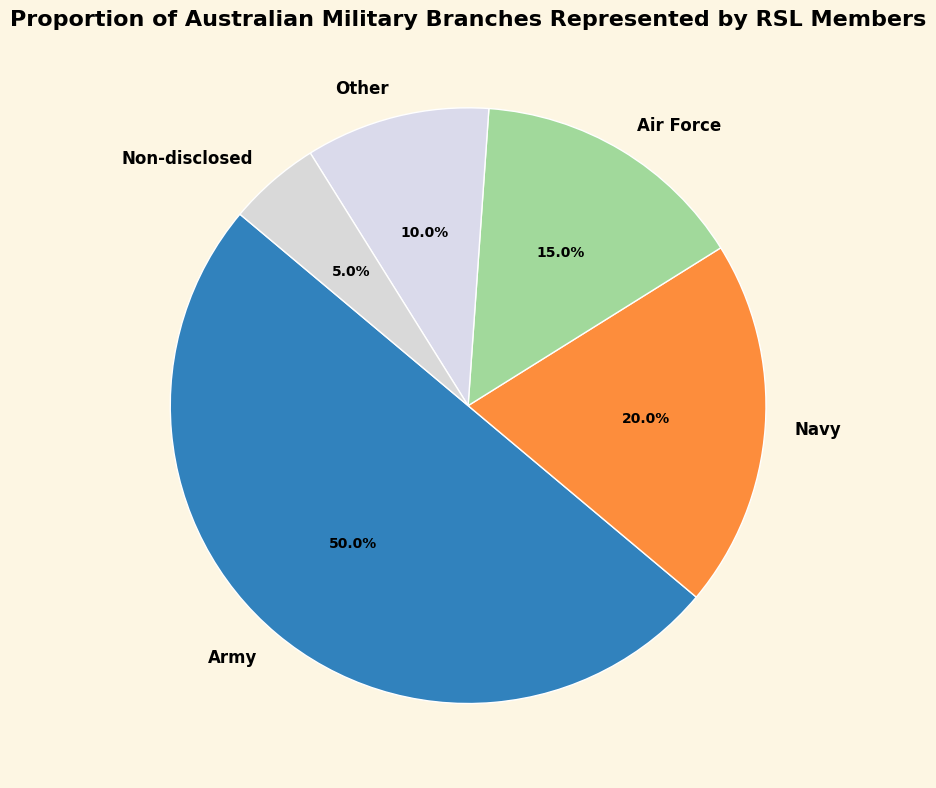What percentage of RSL members are from the Army? According to the pie chart, the proportion of Australian Military Branches represented by RSL members shows that 50% are from the Army.
Answer: 50% Which military branch has the largest representation among RSL members? The pie chart shows the proportions of each branch, and the largest segment is allocated to the Army at 50%.
Answer: Army What is the combined percentage of members from the Navy and Air Force? Looking at the pie chart, the Navy has 20% and the Air Force has 15%. Adding these together, we get 20% + 15% = 35%.
Answer: 35% Is the percentage of RSL members from 'Other' branches higher or lower than those from the 'Non-disclosed' category? The pie chart shows that 'Other' branches make up 10% while the 'Non-disclosed' category is 5%. Therefore, 'Other' is higher than 'Non-disclosed'.
Answer: Higher How does the representation of the Non-disclosed category compare to the Navy? The pie chart shows the Non-disclosed category at 5% and the Navy at 20%. Therefore, the Navy's representation is significantly higher than the Non-disclosed.
Answer: Navy is higher Which category represents the smallest percentage of RSL members? The pie chart indicates that the smallest segment is the 'Non-disclosed' category at 5%.
Answer: Non-disclosed What is the difference in representation between the Army and Air Force? The pie chart shows the Army at 50% and the Air Force at 15%. The difference is 50% - 15% = 35%.
Answer: 35% What is the aggregate percentage of members from the Army, Navy, and Air Force? Referring to the pie chart, the percentages for the Army, Navy, and Air Force are 50%, 20%, and 15% respectively. Adding these, we get 50% + 20% + 15% = 85%.
Answer: 85% What percentage do the 'Other' branches and 'Non-disclosed' category collectively represent? According to the pie chart, 'Other' branches represent 10% and 'Non-disclosed' 5%. Combined, this equals 10% + 5% = 15%.
Answer: 15% If the Army's representation is doubled, what would be the new percentage? The current Army percentage is 50%. If doubled, it becomes 50% * 2 = 100%. However, this scenario isn't practical as it would exceed the total percentage.
Answer: 100% (Hypothetical) 